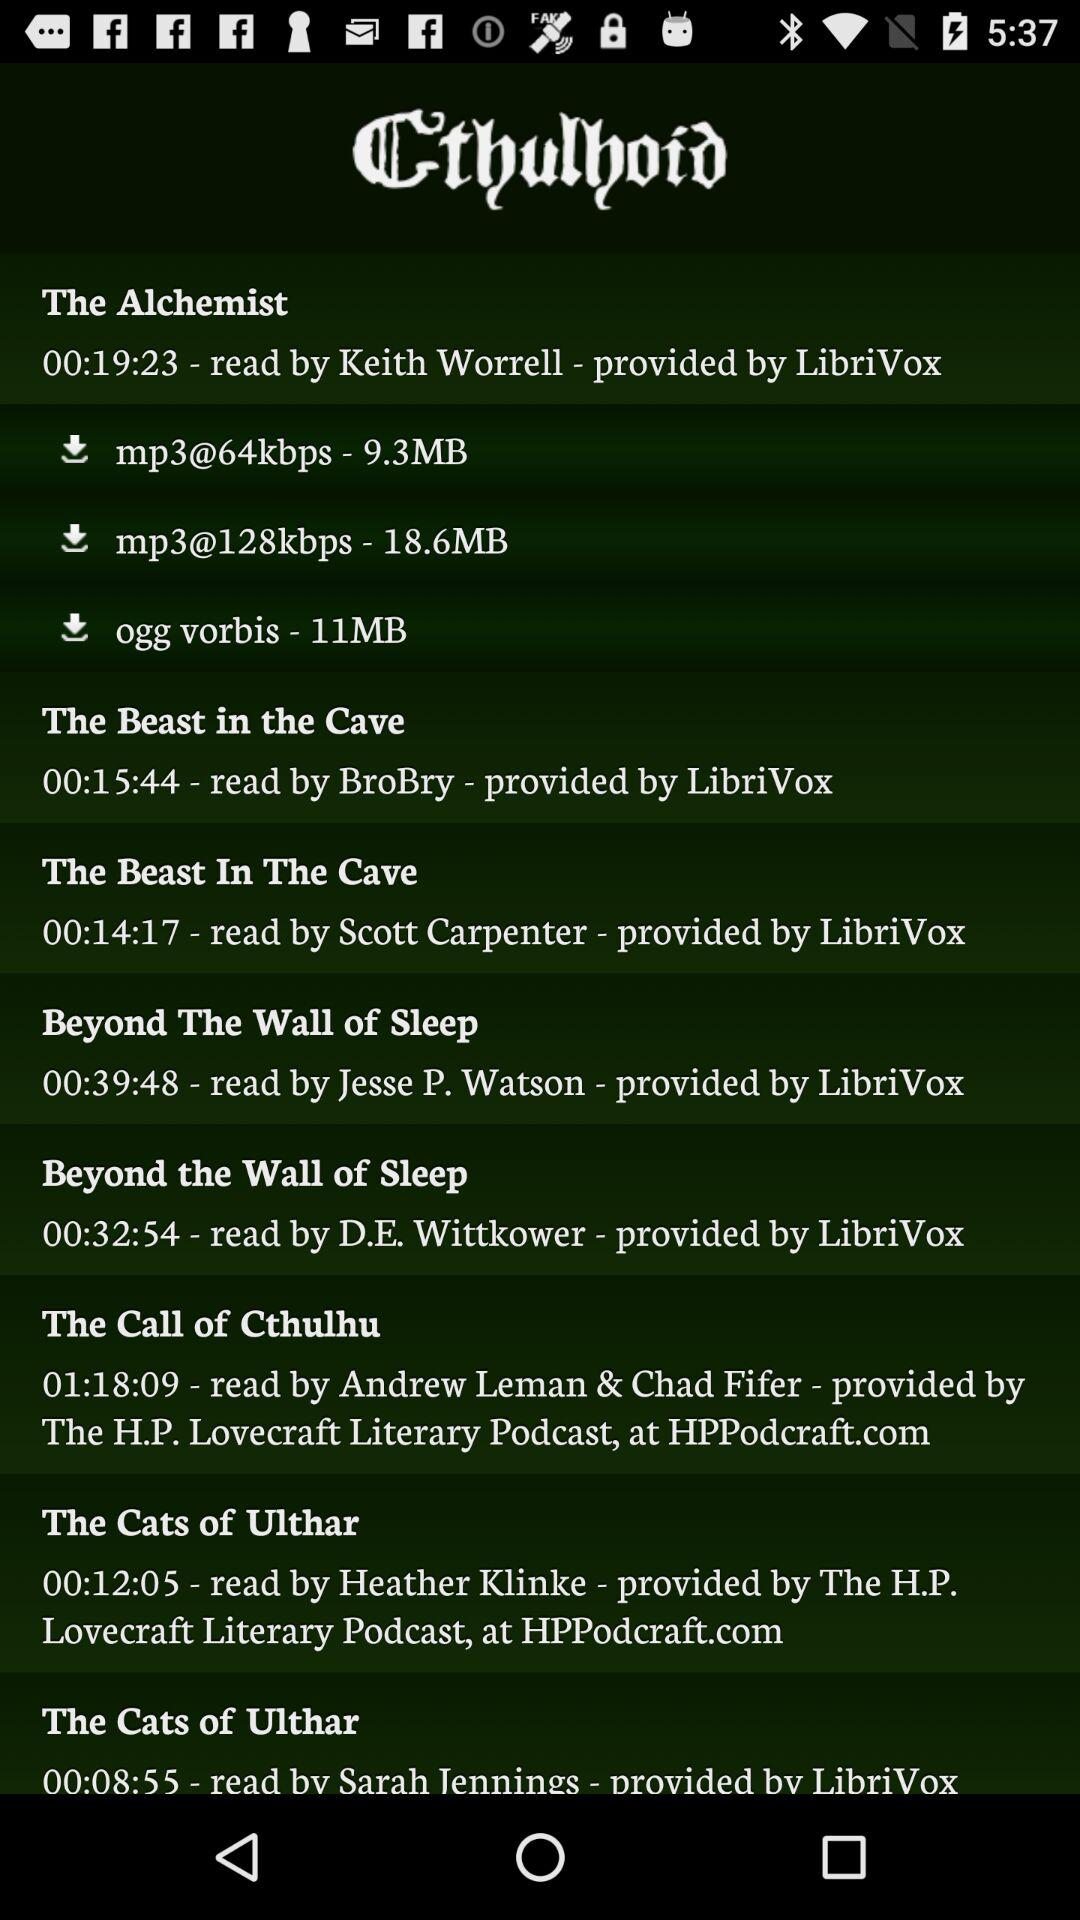What is the name of the reader of "Beyond The Wall of Sleep"? The name of the reader of "Beyond The Wall of Sleep" is Jesse P. Watson. 